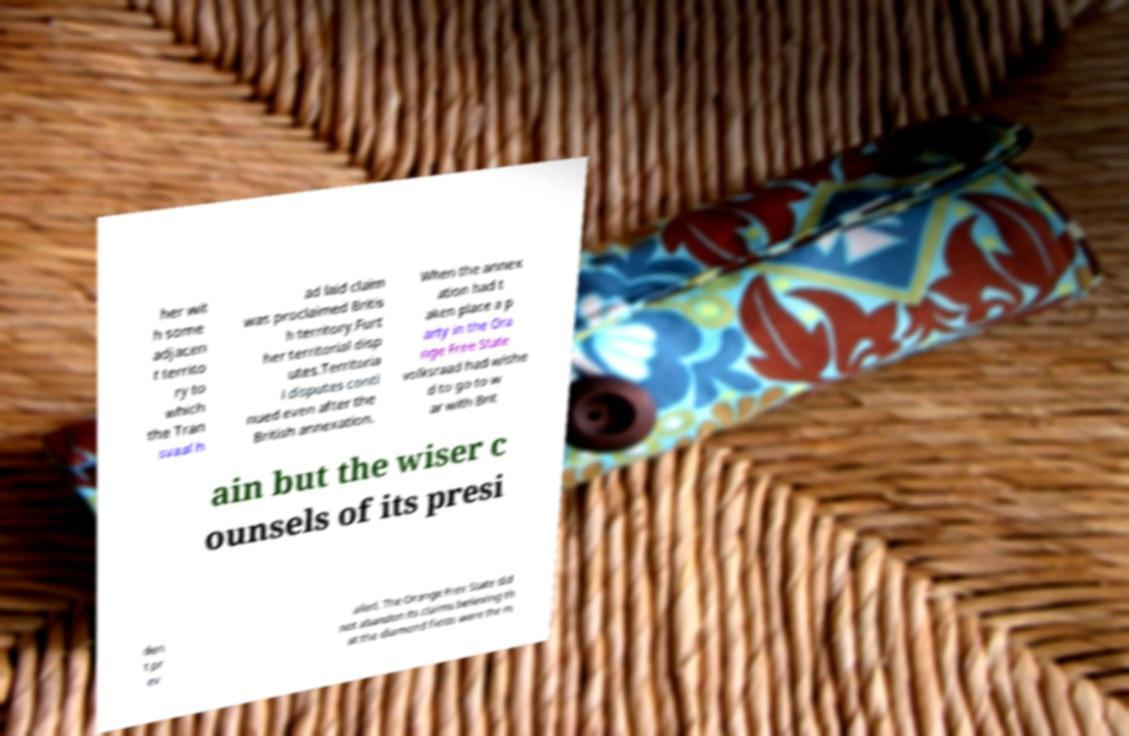Could you assist in decoding the text presented in this image and type it out clearly? her wit h some adjacen t territo ry to which the Tran svaal h ad laid claim was proclaimed Britis h territory.Furt her territorial disp utes.Territoria l disputes conti nued even after the British annexation. When the annex ation had t aken place a p arty in the Ora nge Free State volksraad had wishe d to go to w ar with Brit ain but the wiser c ounsels of its presi den t pr ev ailed. The Orange Free State did not abandon its claims believing th at the diamond fields were the m 